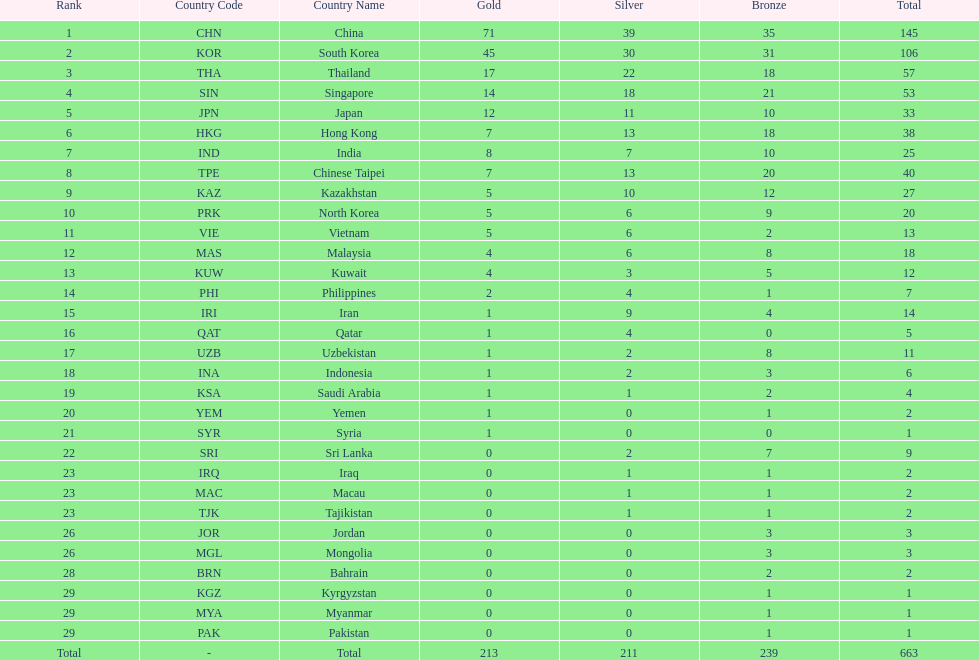How many nations earned at least ten bronze medals? 9. 